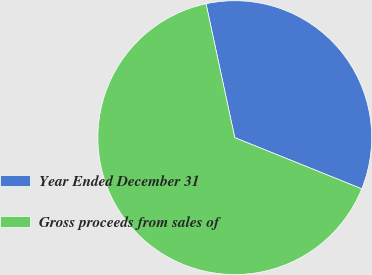<chart> <loc_0><loc_0><loc_500><loc_500><pie_chart><fcel>Year Ended December 31<fcel>Gross proceeds from sales of<nl><fcel>34.47%<fcel>65.53%<nl></chart> 